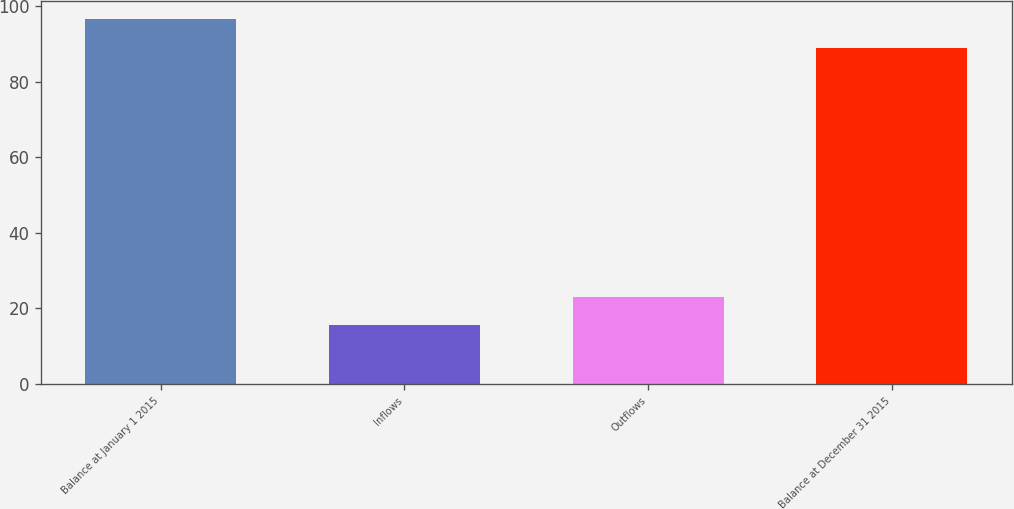<chart> <loc_0><loc_0><loc_500><loc_500><bar_chart><fcel>Balance at January 1 2015<fcel>Inflows<fcel>Outflows<fcel>Balance at December 31 2015<nl><fcel>96.5<fcel>15.6<fcel>23.1<fcel>89<nl></chart> 